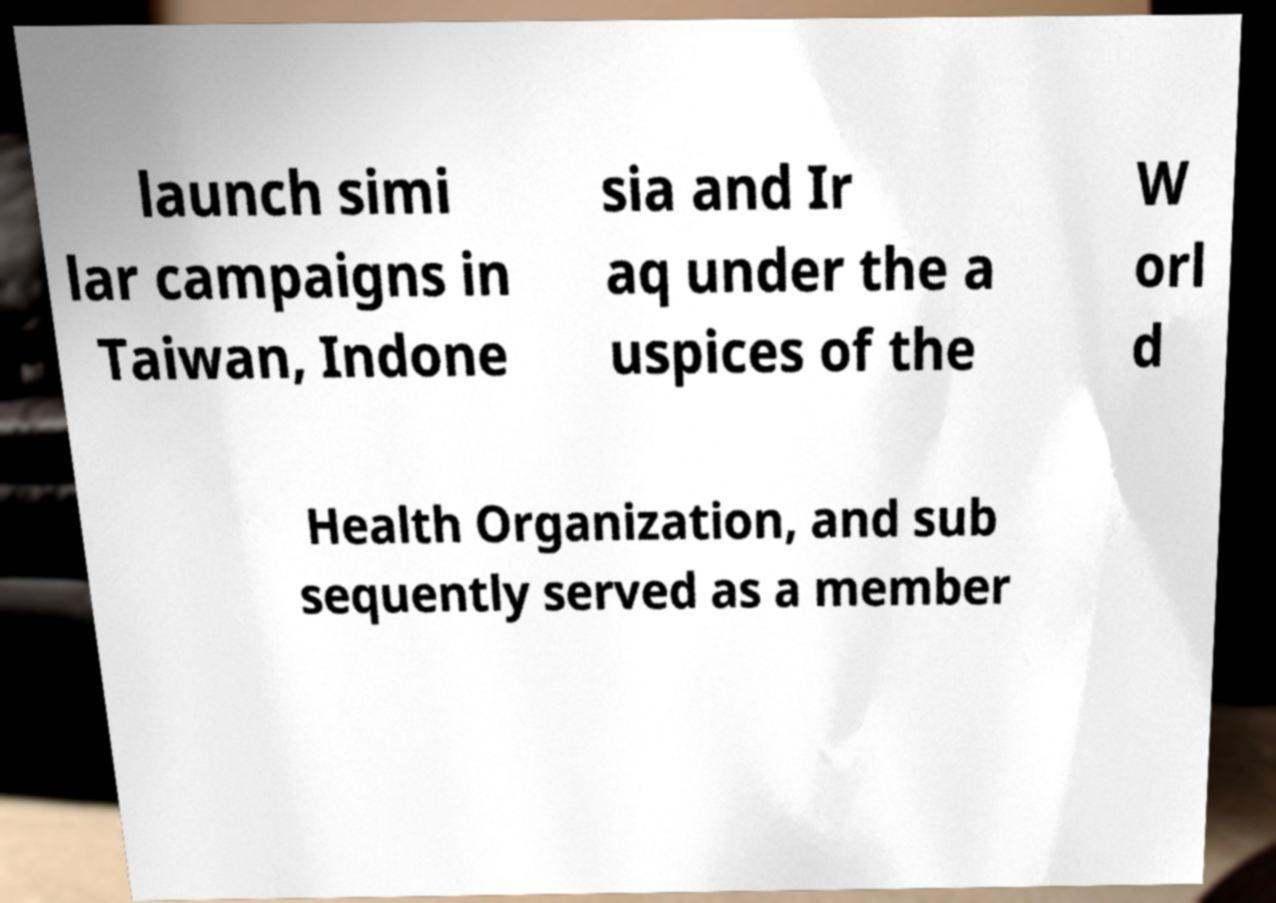Can you accurately transcribe the text from the provided image for me? launch simi lar campaigns in Taiwan, Indone sia and Ir aq under the a uspices of the W orl d Health Organization, and sub sequently served as a member 